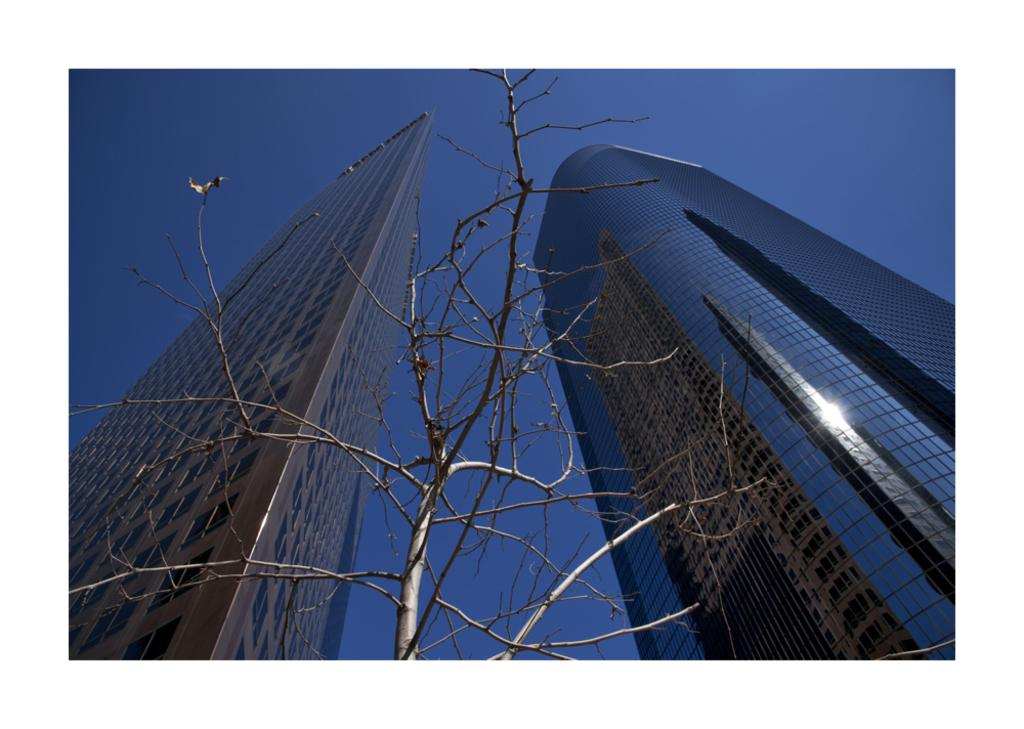What type of plant is visible in the image? There is a tree with no leaves in the image. What type of structures are present in the image? There are tallest buildings in the image. What is visible at the top of the image? The sky is clear at the top of the image. How many fish can be seen swimming in the tree in the image? There are no fish present in the image, as it features a tree with no leaves and tallest buildings. What type of nut is growing on the tallest buildings in the image? There are no nuts growing on the tallest buildings in the image; the image only shows a tree with no leaves and the buildings. 